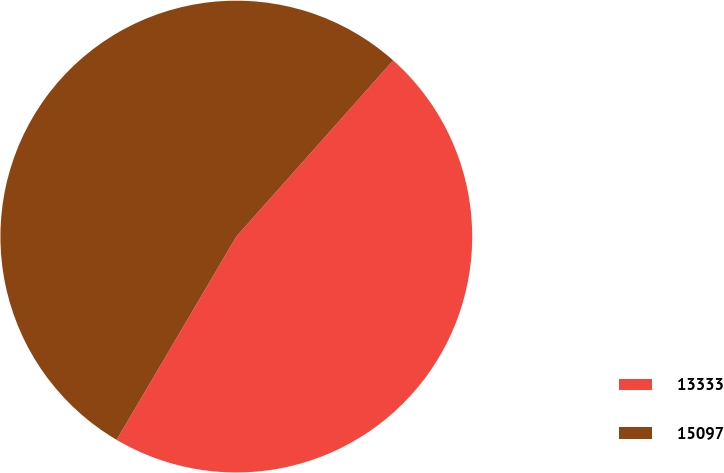Convert chart. <chart><loc_0><loc_0><loc_500><loc_500><pie_chart><fcel>13333<fcel>15097<nl><fcel>46.89%<fcel>53.11%<nl></chart> 